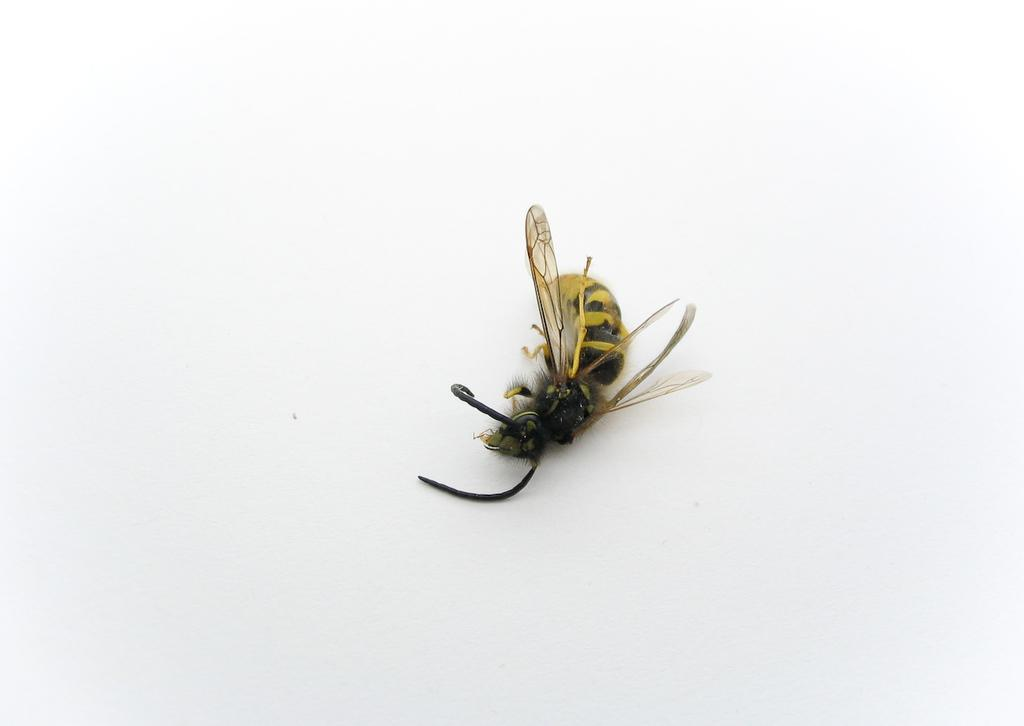What type of insect can be seen in the image? There is a bee in the image. What color is the background of the image? The background of the image is white. What type of hammer is being used by the bee in the image? There is no hammer present in the image, as it features a bee and a white background. 